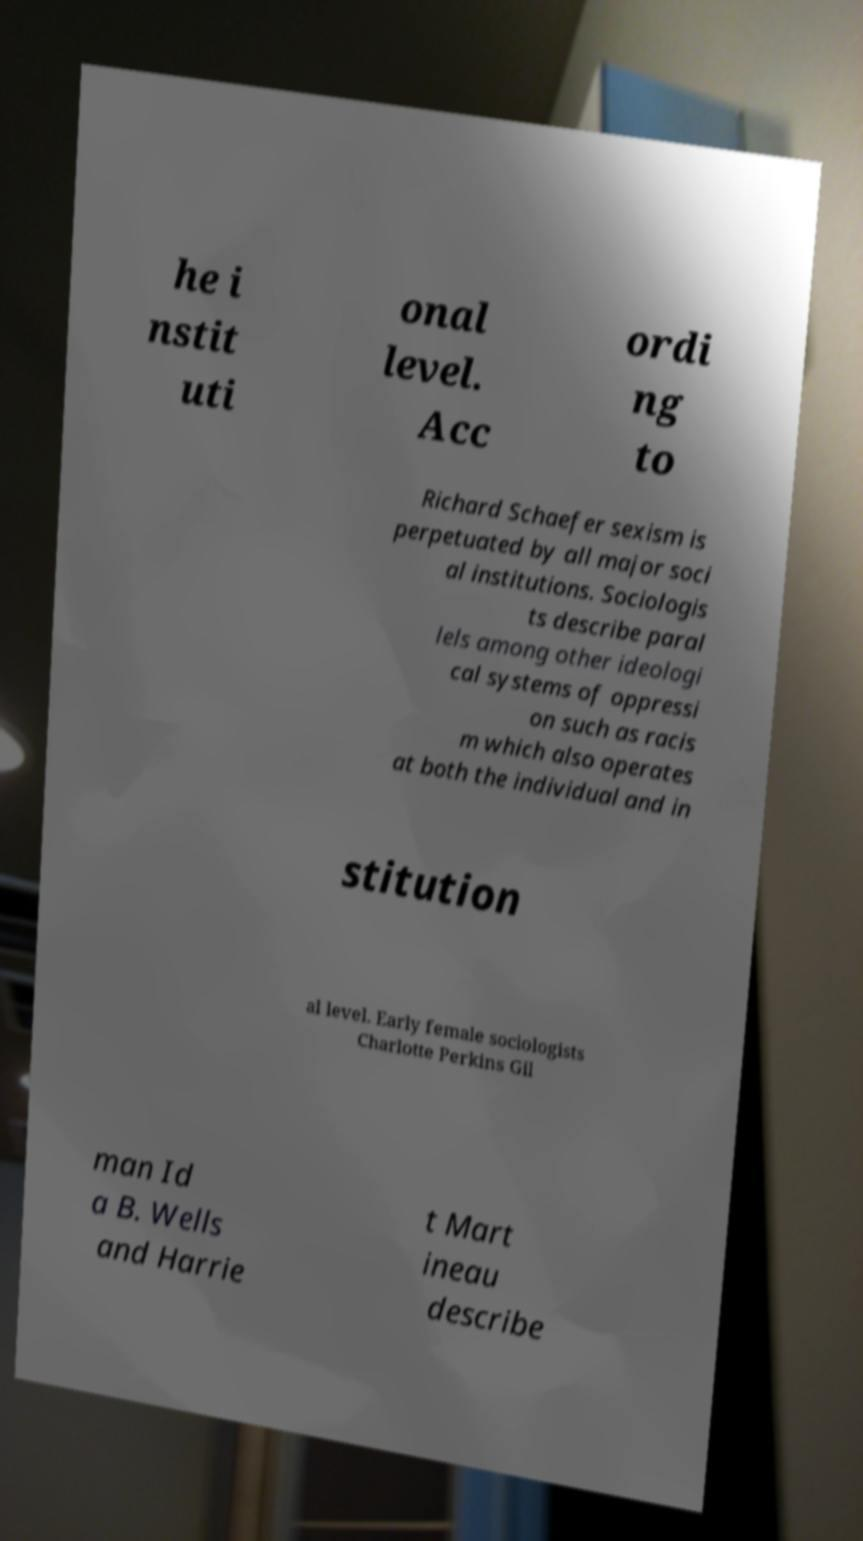Could you assist in decoding the text presented in this image and type it out clearly? he i nstit uti onal level. Acc ordi ng to Richard Schaefer sexism is perpetuated by all major soci al institutions. Sociologis ts describe paral lels among other ideologi cal systems of oppressi on such as racis m which also operates at both the individual and in stitution al level. Early female sociologists Charlotte Perkins Gil man Id a B. Wells and Harrie t Mart ineau describe 